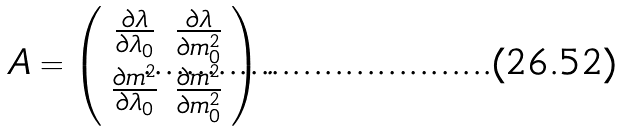Convert formula to latex. <formula><loc_0><loc_0><loc_500><loc_500>A = \left ( \begin{array} { c c } \frac { \partial \lambda } { \partial \lambda _ { 0 } } & \frac { \partial \lambda } { \partial m _ { 0 } ^ { 2 } } \\ \frac { \partial m ^ { 2 } } { \partial \lambda _ { 0 } } & \frac { \partial m ^ { 2 } } { \partial m _ { 0 } ^ { 2 } } \end{array} \right ) .</formula> 